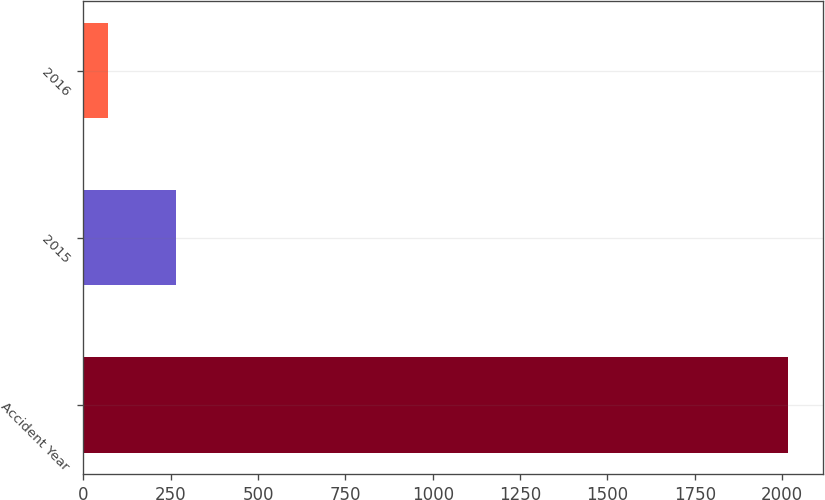Convert chart. <chart><loc_0><loc_0><loc_500><loc_500><bar_chart><fcel>Accident Year<fcel>2015<fcel>2016<nl><fcel>2016<fcel>265.5<fcel>71<nl></chart> 